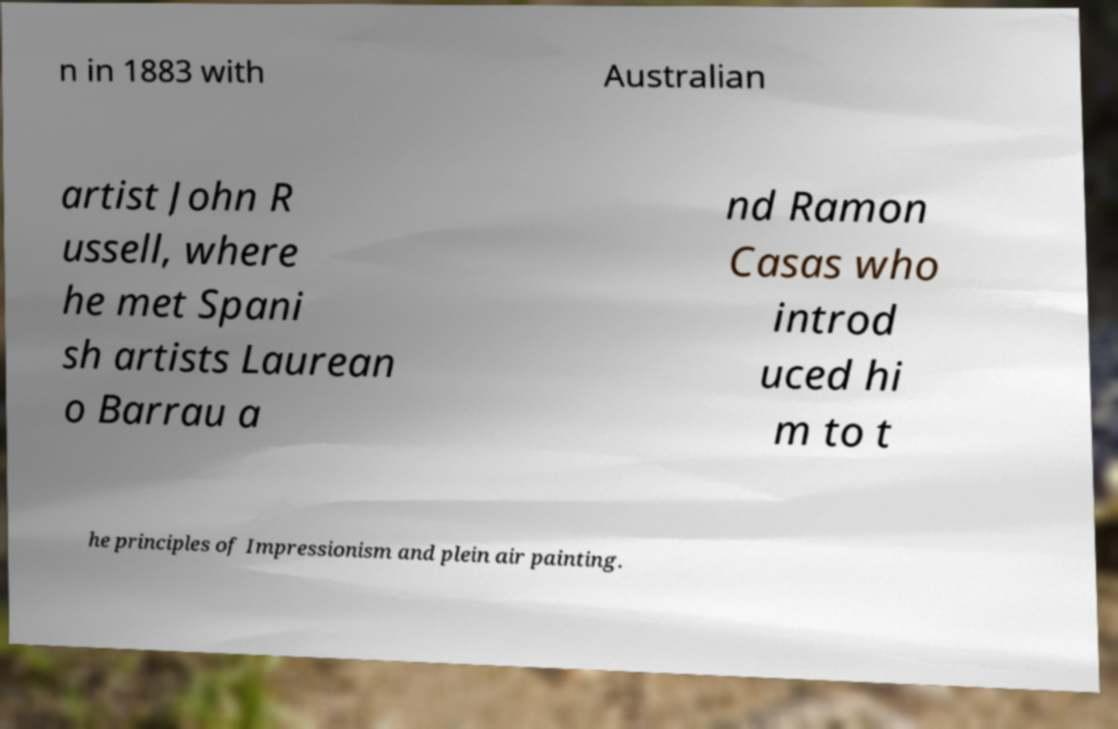Can you accurately transcribe the text from the provided image for me? n in 1883 with Australian artist John R ussell, where he met Spani sh artists Laurean o Barrau a nd Ramon Casas who introd uced hi m to t he principles of Impressionism and plein air painting. 